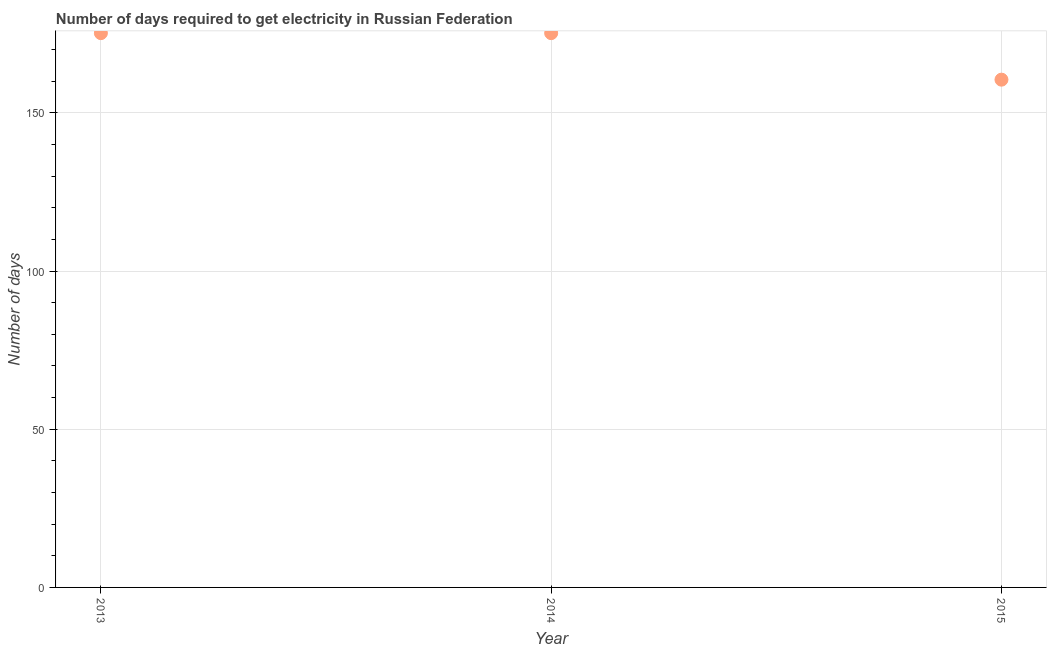What is the time to get electricity in 2013?
Ensure brevity in your answer.  175.2. Across all years, what is the maximum time to get electricity?
Provide a short and direct response. 175.2. Across all years, what is the minimum time to get electricity?
Offer a terse response. 160.5. In which year was the time to get electricity maximum?
Ensure brevity in your answer.  2013. In which year was the time to get electricity minimum?
Offer a terse response. 2015. What is the sum of the time to get electricity?
Offer a terse response. 510.9. What is the average time to get electricity per year?
Offer a very short reply. 170.3. What is the median time to get electricity?
Keep it short and to the point. 175.2. In how many years, is the time to get electricity greater than 90 ?
Make the answer very short. 3. What is the ratio of the time to get electricity in 2013 to that in 2015?
Offer a very short reply. 1.09. What is the difference between the highest and the lowest time to get electricity?
Provide a succinct answer. 14.7. In how many years, is the time to get electricity greater than the average time to get electricity taken over all years?
Offer a very short reply. 2. How many dotlines are there?
Keep it short and to the point. 1. How many years are there in the graph?
Ensure brevity in your answer.  3. What is the difference between two consecutive major ticks on the Y-axis?
Offer a very short reply. 50. What is the title of the graph?
Keep it short and to the point. Number of days required to get electricity in Russian Federation. What is the label or title of the Y-axis?
Your response must be concise. Number of days. What is the Number of days in 2013?
Ensure brevity in your answer.  175.2. What is the Number of days in 2014?
Ensure brevity in your answer.  175.2. What is the Number of days in 2015?
Offer a very short reply. 160.5. What is the difference between the Number of days in 2013 and 2015?
Provide a short and direct response. 14.7. What is the ratio of the Number of days in 2013 to that in 2014?
Offer a very short reply. 1. What is the ratio of the Number of days in 2013 to that in 2015?
Make the answer very short. 1.09. What is the ratio of the Number of days in 2014 to that in 2015?
Your answer should be very brief. 1.09. 